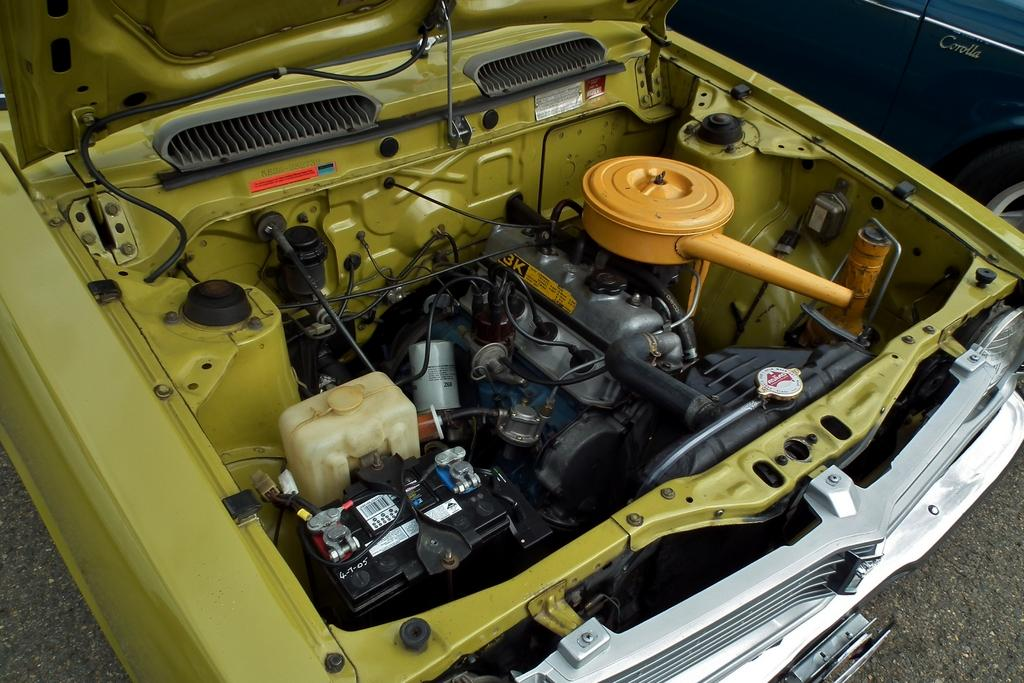What type of vehicles can be seen in the image? There are cars in the image. What specific components of the cars are visible in the image? Car parts, including an engine, are visible in the image. What is the surface on which the cars and car parts are situated? The ground is visible in the image. Where is the library located in the image? There is no library present in the image. What type of scale is used to weigh the car parts in the image? There is no scale visible in the image. 